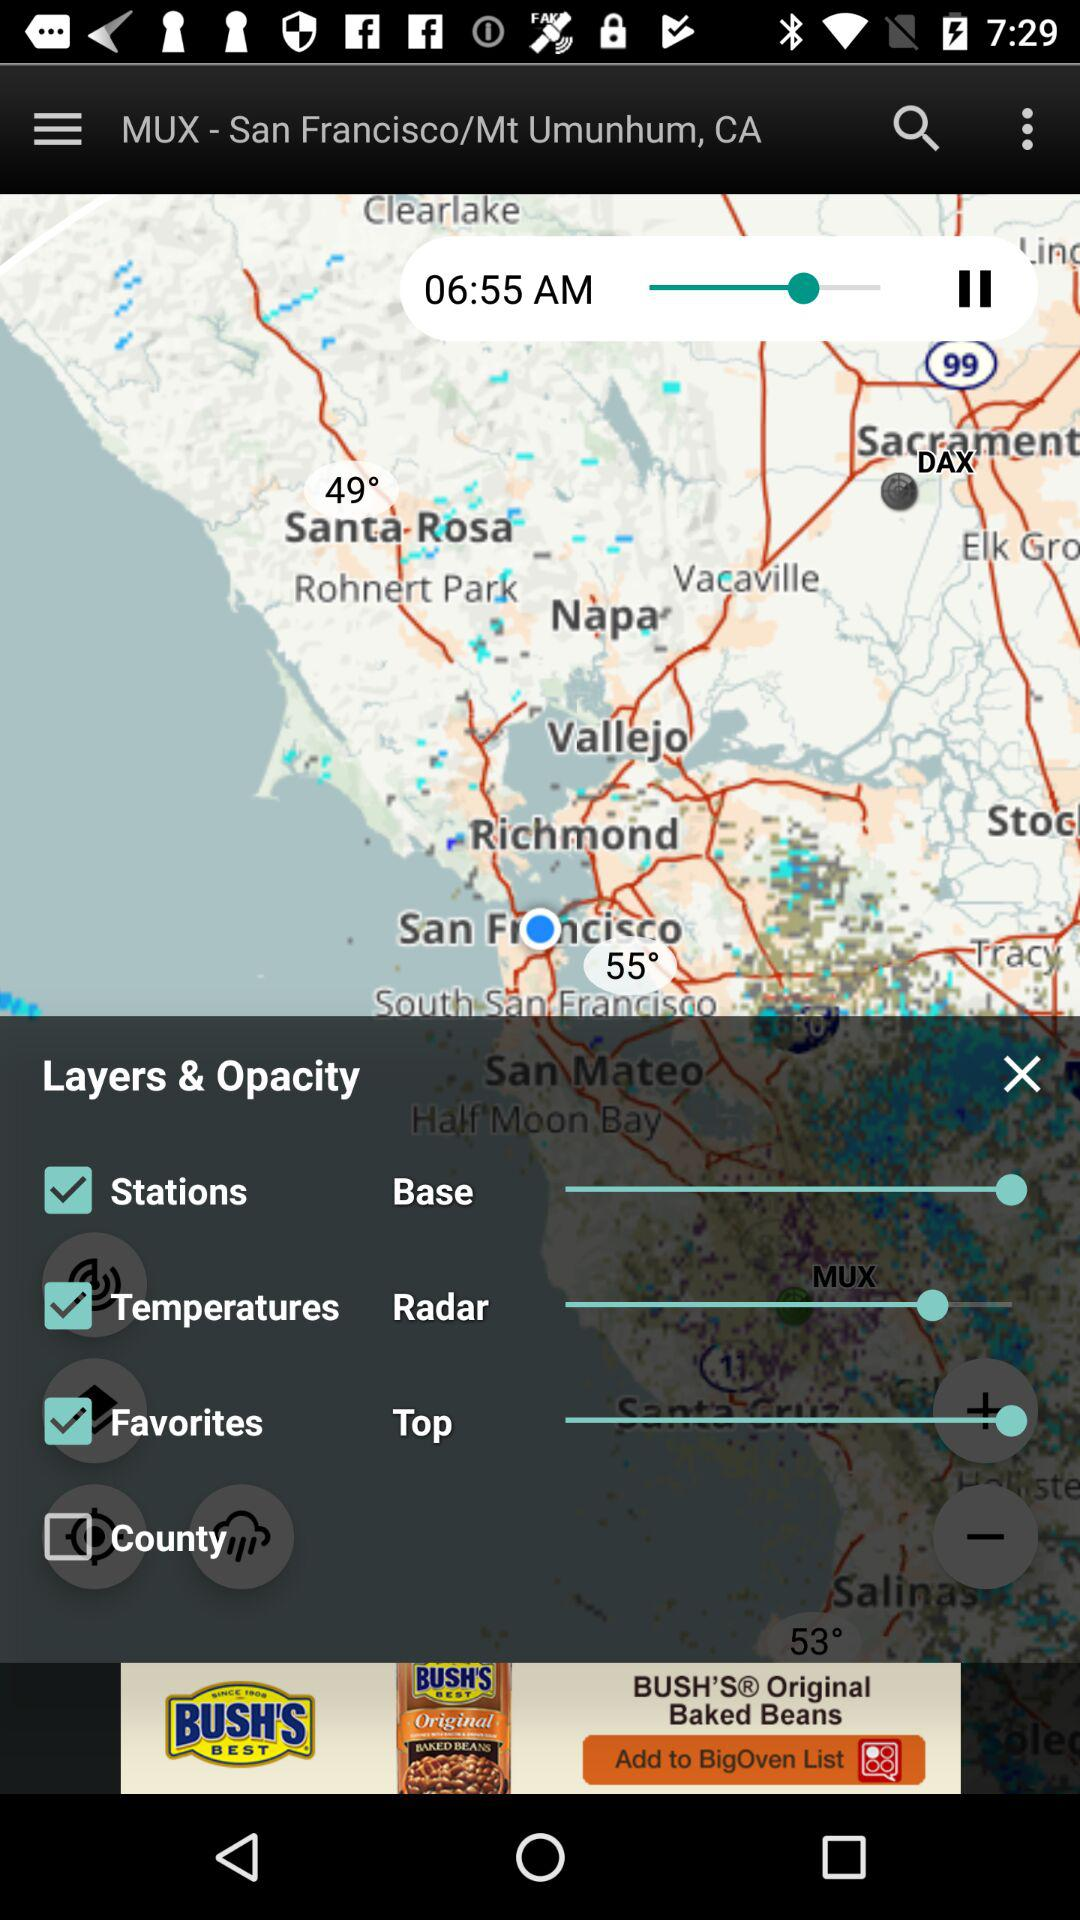What is the time on the map? The time on the map is 06:55 AM. 